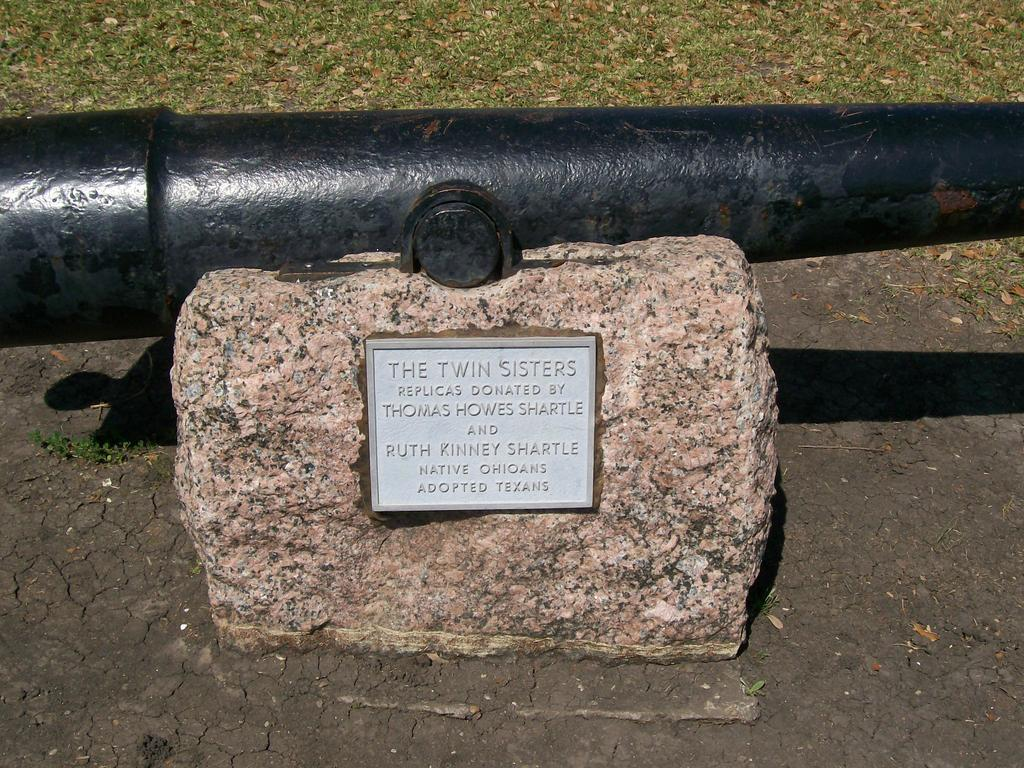What is placed on the rock in the image? There is a board on a rock in the image. What type of object can be seen in the image besides the board and rock? There is a black pipe in the image. What type of vegetation is visible in the image? There is grass visible in the image. What type of recess can be seen in the image? There is no recess present in the image. How many men are visible in the image? There are no men present in the image. 